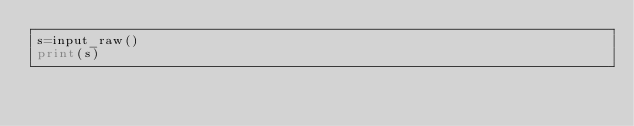Convert code to text. <code><loc_0><loc_0><loc_500><loc_500><_Python_>s=input_raw()
print(s)</code> 